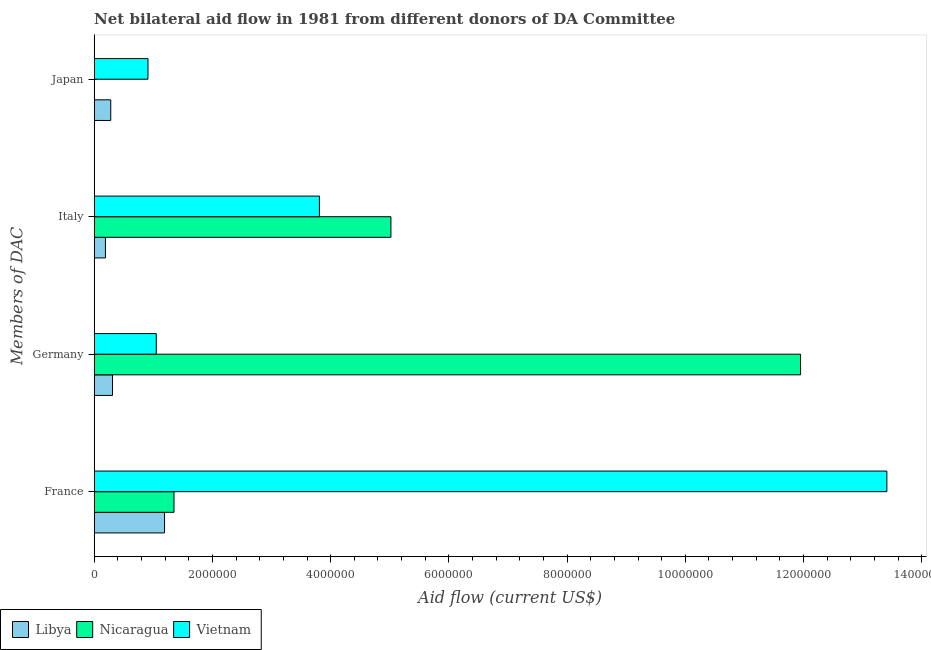How many different coloured bars are there?
Offer a terse response. 3. How many groups of bars are there?
Your answer should be compact. 4. Are the number of bars per tick equal to the number of legend labels?
Give a very brief answer. No. What is the amount of aid given by germany in Vietnam?
Your answer should be compact. 1.05e+06. Across all countries, what is the maximum amount of aid given by japan?
Give a very brief answer. 9.10e+05. Across all countries, what is the minimum amount of aid given by germany?
Offer a terse response. 3.10e+05. In which country was the amount of aid given by germany maximum?
Your answer should be compact. Nicaragua. What is the total amount of aid given by italy in the graph?
Your answer should be compact. 9.02e+06. What is the difference between the amount of aid given by france in Nicaragua and that in Vietnam?
Offer a very short reply. -1.21e+07. What is the difference between the amount of aid given by germany in Vietnam and the amount of aid given by france in Libya?
Make the answer very short. -1.40e+05. What is the average amount of aid given by italy per country?
Offer a very short reply. 3.01e+06. What is the difference between the amount of aid given by japan and amount of aid given by france in Libya?
Offer a terse response. -9.10e+05. In how many countries, is the amount of aid given by france greater than 3600000 US$?
Provide a short and direct response. 1. What is the ratio of the amount of aid given by italy in Libya to that in Vietnam?
Keep it short and to the point. 0.05. Is the difference between the amount of aid given by france in Libya and Vietnam greater than the difference between the amount of aid given by italy in Libya and Vietnam?
Give a very brief answer. No. What is the difference between the highest and the second highest amount of aid given by germany?
Offer a terse response. 1.09e+07. What is the difference between the highest and the lowest amount of aid given by germany?
Your answer should be compact. 1.16e+07. In how many countries, is the amount of aid given by japan greater than the average amount of aid given by japan taken over all countries?
Give a very brief answer. 1. Is the sum of the amount of aid given by france in Libya and Vietnam greater than the maximum amount of aid given by italy across all countries?
Offer a very short reply. Yes. How many bars are there?
Make the answer very short. 11. What is the difference between two consecutive major ticks on the X-axis?
Ensure brevity in your answer.  2.00e+06. Does the graph contain any zero values?
Your answer should be very brief. Yes. Where does the legend appear in the graph?
Offer a terse response. Bottom left. How are the legend labels stacked?
Ensure brevity in your answer.  Horizontal. What is the title of the graph?
Your response must be concise. Net bilateral aid flow in 1981 from different donors of DA Committee. What is the label or title of the X-axis?
Your answer should be compact. Aid flow (current US$). What is the label or title of the Y-axis?
Offer a very short reply. Members of DAC. What is the Aid flow (current US$) in Libya in France?
Ensure brevity in your answer.  1.19e+06. What is the Aid flow (current US$) of Nicaragua in France?
Keep it short and to the point. 1.35e+06. What is the Aid flow (current US$) of Vietnam in France?
Your response must be concise. 1.34e+07. What is the Aid flow (current US$) of Libya in Germany?
Offer a terse response. 3.10e+05. What is the Aid flow (current US$) in Nicaragua in Germany?
Your answer should be very brief. 1.20e+07. What is the Aid flow (current US$) in Vietnam in Germany?
Provide a short and direct response. 1.05e+06. What is the Aid flow (current US$) in Libya in Italy?
Keep it short and to the point. 1.90e+05. What is the Aid flow (current US$) in Nicaragua in Italy?
Keep it short and to the point. 5.02e+06. What is the Aid flow (current US$) of Vietnam in Italy?
Provide a short and direct response. 3.81e+06. What is the Aid flow (current US$) in Nicaragua in Japan?
Ensure brevity in your answer.  0. What is the Aid flow (current US$) in Vietnam in Japan?
Keep it short and to the point. 9.10e+05. Across all Members of DAC, what is the maximum Aid flow (current US$) in Libya?
Offer a terse response. 1.19e+06. Across all Members of DAC, what is the maximum Aid flow (current US$) of Nicaragua?
Ensure brevity in your answer.  1.20e+07. Across all Members of DAC, what is the maximum Aid flow (current US$) in Vietnam?
Ensure brevity in your answer.  1.34e+07. Across all Members of DAC, what is the minimum Aid flow (current US$) of Libya?
Make the answer very short. 1.90e+05. Across all Members of DAC, what is the minimum Aid flow (current US$) in Vietnam?
Provide a short and direct response. 9.10e+05. What is the total Aid flow (current US$) in Libya in the graph?
Your answer should be very brief. 1.97e+06. What is the total Aid flow (current US$) of Nicaragua in the graph?
Give a very brief answer. 1.83e+07. What is the total Aid flow (current US$) in Vietnam in the graph?
Offer a very short reply. 1.92e+07. What is the difference between the Aid flow (current US$) in Libya in France and that in Germany?
Your answer should be compact. 8.80e+05. What is the difference between the Aid flow (current US$) of Nicaragua in France and that in Germany?
Offer a terse response. -1.06e+07. What is the difference between the Aid flow (current US$) in Vietnam in France and that in Germany?
Your response must be concise. 1.24e+07. What is the difference between the Aid flow (current US$) of Libya in France and that in Italy?
Keep it short and to the point. 1.00e+06. What is the difference between the Aid flow (current US$) in Nicaragua in France and that in Italy?
Offer a very short reply. -3.67e+06. What is the difference between the Aid flow (current US$) of Vietnam in France and that in Italy?
Offer a terse response. 9.60e+06. What is the difference between the Aid flow (current US$) in Libya in France and that in Japan?
Provide a succinct answer. 9.10e+05. What is the difference between the Aid flow (current US$) of Vietnam in France and that in Japan?
Your answer should be very brief. 1.25e+07. What is the difference between the Aid flow (current US$) of Libya in Germany and that in Italy?
Your answer should be compact. 1.20e+05. What is the difference between the Aid flow (current US$) of Nicaragua in Germany and that in Italy?
Your response must be concise. 6.93e+06. What is the difference between the Aid flow (current US$) in Vietnam in Germany and that in Italy?
Provide a short and direct response. -2.76e+06. What is the difference between the Aid flow (current US$) in Vietnam in Germany and that in Japan?
Ensure brevity in your answer.  1.40e+05. What is the difference between the Aid flow (current US$) in Libya in Italy and that in Japan?
Provide a short and direct response. -9.00e+04. What is the difference between the Aid flow (current US$) of Vietnam in Italy and that in Japan?
Give a very brief answer. 2.90e+06. What is the difference between the Aid flow (current US$) in Libya in France and the Aid flow (current US$) in Nicaragua in Germany?
Make the answer very short. -1.08e+07. What is the difference between the Aid flow (current US$) of Libya in France and the Aid flow (current US$) of Vietnam in Germany?
Provide a succinct answer. 1.40e+05. What is the difference between the Aid flow (current US$) in Nicaragua in France and the Aid flow (current US$) in Vietnam in Germany?
Ensure brevity in your answer.  3.00e+05. What is the difference between the Aid flow (current US$) of Libya in France and the Aid flow (current US$) of Nicaragua in Italy?
Give a very brief answer. -3.83e+06. What is the difference between the Aid flow (current US$) of Libya in France and the Aid flow (current US$) of Vietnam in Italy?
Give a very brief answer. -2.62e+06. What is the difference between the Aid flow (current US$) in Nicaragua in France and the Aid flow (current US$) in Vietnam in Italy?
Give a very brief answer. -2.46e+06. What is the difference between the Aid flow (current US$) in Libya in Germany and the Aid flow (current US$) in Nicaragua in Italy?
Offer a very short reply. -4.71e+06. What is the difference between the Aid flow (current US$) of Libya in Germany and the Aid flow (current US$) of Vietnam in Italy?
Give a very brief answer. -3.50e+06. What is the difference between the Aid flow (current US$) in Nicaragua in Germany and the Aid flow (current US$) in Vietnam in Italy?
Give a very brief answer. 8.14e+06. What is the difference between the Aid flow (current US$) of Libya in Germany and the Aid flow (current US$) of Vietnam in Japan?
Give a very brief answer. -6.00e+05. What is the difference between the Aid flow (current US$) in Nicaragua in Germany and the Aid flow (current US$) in Vietnam in Japan?
Your response must be concise. 1.10e+07. What is the difference between the Aid flow (current US$) in Libya in Italy and the Aid flow (current US$) in Vietnam in Japan?
Make the answer very short. -7.20e+05. What is the difference between the Aid flow (current US$) in Nicaragua in Italy and the Aid flow (current US$) in Vietnam in Japan?
Make the answer very short. 4.11e+06. What is the average Aid flow (current US$) of Libya per Members of DAC?
Offer a terse response. 4.92e+05. What is the average Aid flow (current US$) of Nicaragua per Members of DAC?
Provide a succinct answer. 4.58e+06. What is the average Aid flow (current US$) in Vietnam per Members of DAC?
Your answer should be very brief. 4.80e+06. What is the difference between the Aid flow (current US$) in Libya and Aid flow (current US$) in Nicaragua in France?
Provide a short and direct response. -1.60e+05. What is the difference between the Aid flow (current US$) of Libya and Aid flow (current US$) of Vietnam in France?
Give a very brief answer. -1.22e+07. What is the difference between the Aid flow (current US$) of Nicaragua and Aid flow (current US$) of Vietnam in France?
Offer a terse response. -1.21e+07. What is the difference between the Aid flow (current US$) of Libya and Aid flow (current US$) of Nicaragua in Germany?
Make the answer very short. -1.16e+07. What is the difference between the Aid flow (current US$) in Libya and Aid flow (current US$) in Vietnam in Germany?
Keep it short and to the point. -7.40e+05. What is the difference between the Aid flow (current US$) of Nicaragua and Aid flow (current US$) of Vietnam in Germany?
Make the answer very short. 1.09e+07. What is the difference between the Aid flow (current US$) of Libya and Aid flow (current US$) of Nicaragua in Italy?
Keep it short and to the point. -4.83e+06. What is the difference between the Aid flow (current US$) in Libya and Aid flow (current US$) in Vietnam in Italy?
Your answer should be very brief. -3.62e+06. What is the difference between the Aid flow (current US$) in Nicaragua and Aid flow (current US$) in Vietnam in Italy?
Ensure brevity in your answer.  1.21e+06. What is the difference between the Aid flow (current US$) of Libya and Aid flow (current US$) of Vietnam in Japan?
Ensure brevity in your answer.  -6.30e+05. What is the ratio of the Aid flow (current US$) of Libya in France to that in Germany?
Your answer should be compact. 3.84. What is the ratio of the Aid flow (current US$) in Nicaragua in France to that in Germany?
Ensure brevity in your answer.  0.11. What is the ratio of the Aid flow (current US$) of Vietnam in France to that in Germany?
Make the answer very short. 12.77. What is the ratio of the Aid flow (current US$) of Libya in France to that in Italy?
Keep it short and to the point. 6.26. What is the ratio of the Aid flow (current US$) of Nicaragua in France to that in Italy?
Provide a short and direct response. 0.27. What is the ratio of the Aid flow (current US$) of Vietnam in France to that in Italy?
Your response must be concise. 3.52. What is the ratio of the Aid flow (current US$) in Libya in France to that in Japan?
Make the answer very short. 4.25. What is the ratio of the Aid flow (current US$) of Vietnam in France to that in Japan?
Your response must be concise. 14.74. What is the ratio of the Aid flow (current US$) of Libya in Germany to that in Italy?
Give a very brief answer. 1.63. What is the ratio of the Aid flow (current US$) of Nicaragua in Germany to that in Italy?
Offer a very short reply. 2.38. What is the ratio of the Aid flow (current US$) in Vietnam in Germany to that in Italy?
Give a very brief answer. 0.28. What is the ratio of the Aid flow (current US$) of Libya in Germany to that in Japan?
Provide a short and direct response. 1.11. What is the ratio of the Aid flow (current US$) of Vietnam in Germany to that in Japan?
Provide a succinct answer. 1.15. What is the ratio of the Aid flow (current US$) of Libya in Italy to that in Japan?
Keep it short and to the point. 0.68. What is the ratio of the Aid flow (current US$) of Vietnam in Italy to that in Japan?
Offer a very short reply. 4.19. What is the difference between the highest and the second highest Aid flow (current US$) in Libya?
Your answer should be very brief. 8.80e+05. What is the difference between the highest and the second highest Aid flow (current US$) of Nicaragua?
Offer a very short reply. 6.93e+06. What is the difference between the highest and the second highest Aid flow (current US$) of Vietnam?
Give a very brief answer. 9.60e+06. What is the difference between the highest and the lowest Aid flow (current US$) in Nicaragua?
Ensure brevity in your answer.  1.20e+07. What is the difference between the highest and the lowest Aid flow (current US$) of Vietnam?
Make the answer very short. 1.25e+07. 